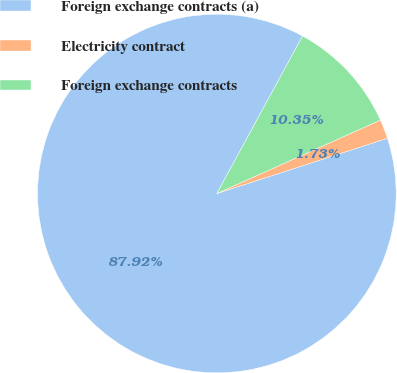Convert chart to OTSL. <chart><loc_0><loc_0><loc_500><loc_500><pie_chart><fcel>Foreign exchange contracts (a)<fcel>Electricity contract<fcel>Foreign exchange contracts<nl><fcel>87.92%<fcel>1.73%<fcel>10.35%<nl></chart> 